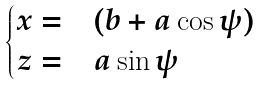<formula> <loc_0><loc_0><loc_500><loc_500>\begin{cases} x = & ( b + a \cos \psi ) \\ z = & a \sin \psi \end{cases}</formula> 